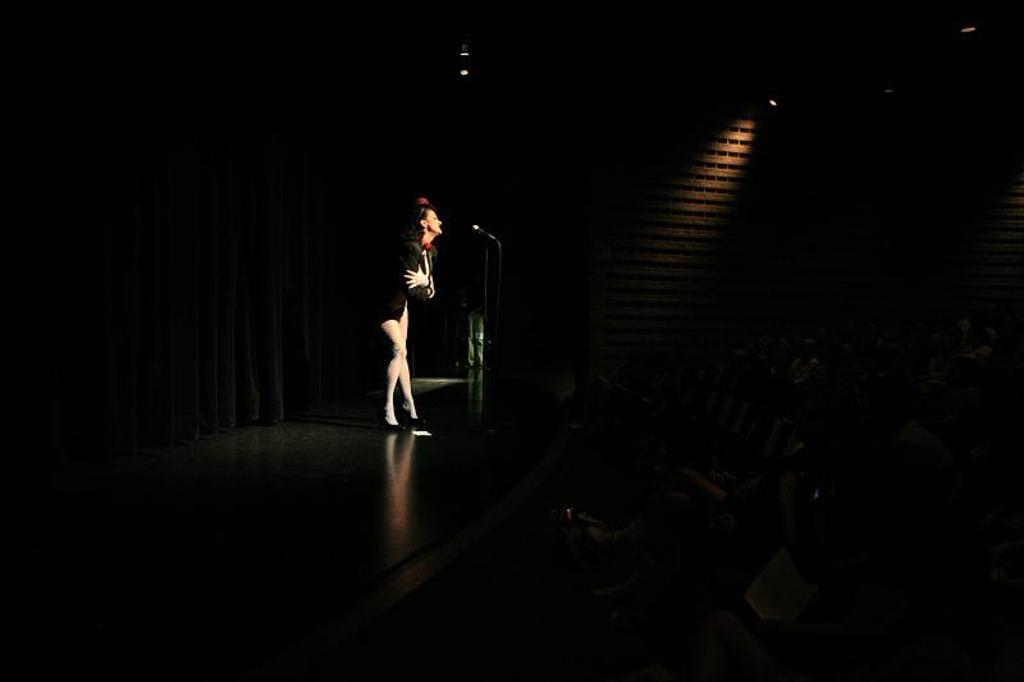How would you summarize this image in a sentence or two? In the middle a beautiful woman is standing and singing, she wore a black color dress. 